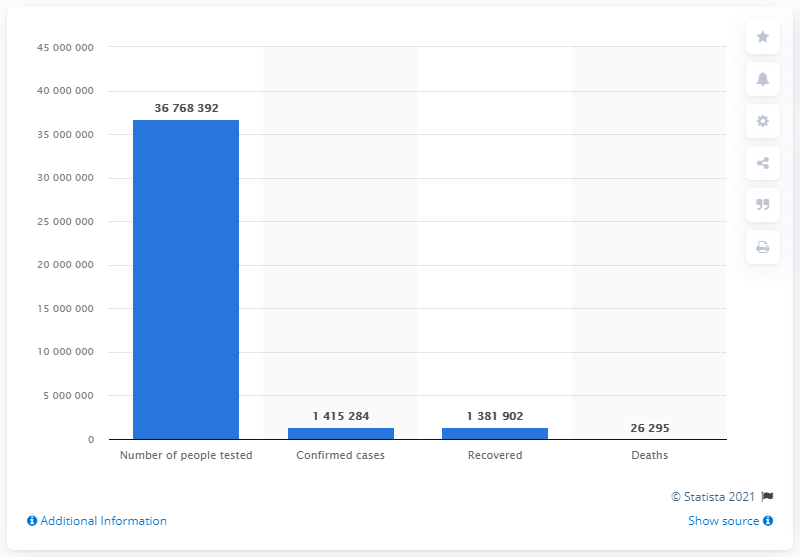Mention a couple of crucial points in this snapshot. 367,683,920 people have been tested for COVID-19 infection. 